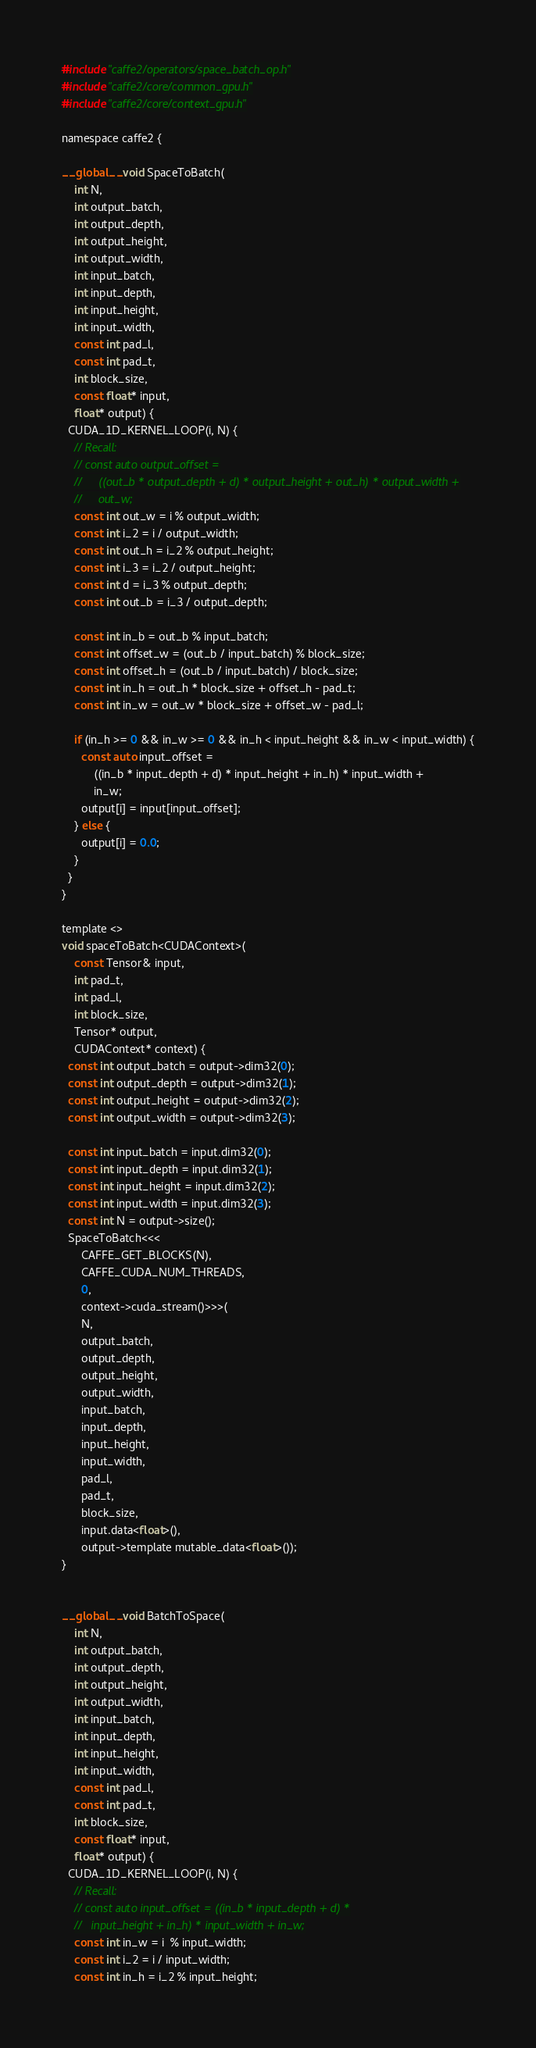Convert code to text. <code><loc_0><loc_0><loc_500><loc_500><_Cuda_>#include "caffe2/operators/space_batch_op.h"
#include "caffe2/core/common_gpu.h"
#include "caffe2/core/context_gpu.h"

namespace caffe2 {

__global__ void SpaceToBatch(
    int N,
    int output_batch,
    int output_depth,
    int output_height,
    int output_width,
    int input_batch,
    int input_depth,
    int input_height,
    int input_width,
    const int pad_l,
    const int pad_t,
    int block_size,
    const float* input,
    float* output) {
  CUDA_1D_KERNEL_LOOP(i, N) {
    // Recall:
    // const auto output_offset =
    //     ((out_b * output_depth + d) * output_height + out_h) * output_width +
    //     out_w;
    const int out_w = i % output_width;
    const int i_2 = i / output_width;
    const int out_h = i_2 % output_height;
    const int i_3 = i_2 / output_height;
    const int d = i_3 % output_depth;
    const int out_b = i_3 / output_depth;

    const int in_b = out_b % input_batch;
    const int offset_w = (out_b / input_batch) % block_size;
    const int offset_h = (out_b / input_batch) / block_size;
    const int in_h = out_h * block_size + offset_h - pad_t;
    const int in_w = out_w * block_size + offset_w - pad_l;

    if (in_h >= 0 && in_w >= 0 && in_h < input_height && in_w < input_width) {
      const auto input_offset =
          ((in_b * input_depth + d) * input_height + in_h) * input_width +
          in_w;
      output[i] = input[input_offset];
    } else {
      output[i] = 0.0;
    }
  }
}

template <>
void spaceToBatch<CUDAContext>(
    const Tensor& input,
    int pad_t,
    int pad_l,
    int block_size,
    Tensor* output,
    CUDAContext* context) {
  const int output_batch = output->dim32(0);
  const int output_depth = output->dim32(1);
  const int output_height = output->dim32(2);
  const int output_width = output->dim32(3);

  const int input_batch = input.dim32(0);
  const int input_depth = input.dim32(1);
  const int input_height = input.dim32(2);
  const int input_width = input.dim32(3);
  const int N = output->size();
  SpaceToBatch<<<
      CAFFE_GET_BLOCKS(N),
      CAFFE_CUDA_NUM_THREADS,
      0,
      context->cuda_stream()>>>(
      N,
      output_batch,
      output_depth,
      output_height,
      output_width,
      input_batch,
      input_depth,
      input_height,
      input_width,
      pad_l,
      pad_t,
      block_size,
      input.data<float>(),
      output->template mutable_data<float>());
}


__global__ void BatchToSpace(
    int N,
    int output_batch,
    int output_depth,
    int output_height,
    int output_width,
    int input_batch,
    int input_depth,
    int input_height,
    int input_width,
    const int pad_l,
    const int pad_t,
    int block_size,
    const float* input,
    float* output) {
  CUDA_1D_KERNEL_LOOP(i, N) {
    // Recall:
    // const auto input_offset = ((in_b * input_depth + d) *
    //   input_height + in_h) * input_width + in_w;
    const int in_w = i  % input_width;
    const int i_2 = i / input_width;
    const int in_h = i_2 % input_height;</code> 